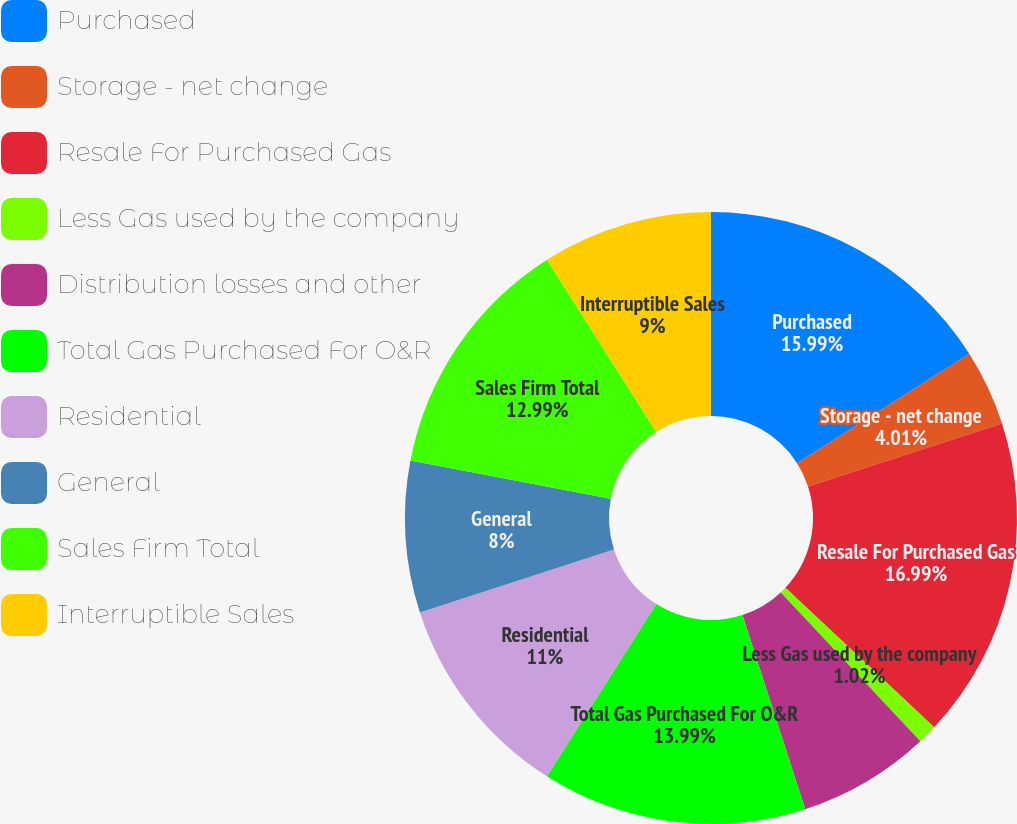Convert chart to OTSL. <chart><loc_0><loc_0><loc_500><loc_500><pie_chart><fcel>Purchased<fcel>Storage - net change<fcel>Resale For Purchased Gas<fcel>Less Gas used by the company<fcel>Distribution losses and other<fcel>Total Gas Purchased For O&R<fcel>Residential<fcel>General<fcel>Sales Firm Total<fcel>Interruptible Sales<nl><fcel>15.99%<fcel>4.01%<fcel>16.99%<fcel>1.02%<fcel>7.01%<fcel>13.99%<fcel>11.0%<fcel>8.0%<fcel>12.99%<fcel>9.0%<nl></chart> 